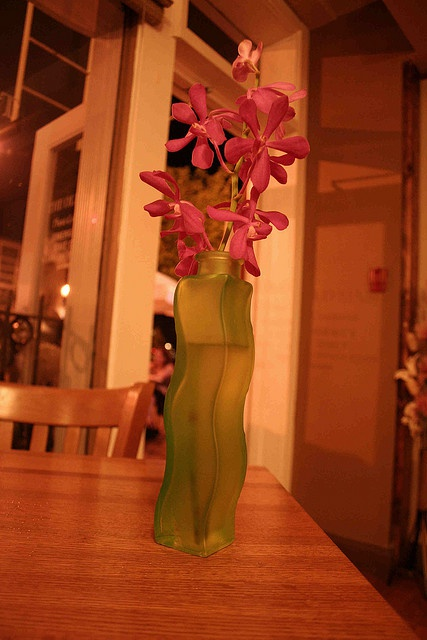Describe the objects in this image and their specific colors. I can see dining table in black, brown, red, and maroon tones, vase in black, brown, maroon, and orange tones, and chair in black, brown, red, and maroon tones in this image. 